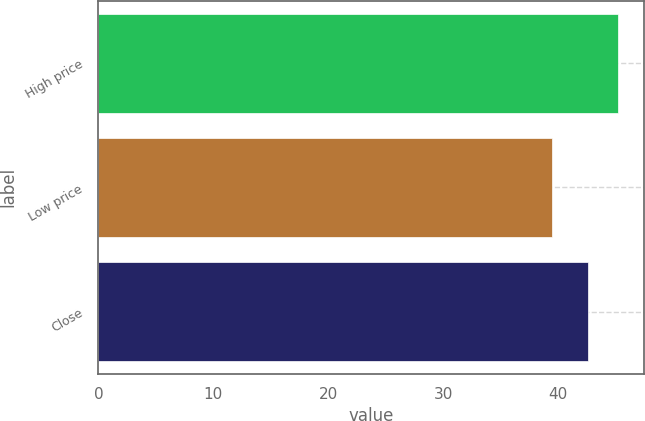Convert chart to OTSL. <chart><loc_0><loc_0><loc_500><loc_500><bar_chart><fcel>High price<fcel>Low price<fcel>Close<nl><fcel>45.27<fcel>39.51<fcel>42.61<nl></chart> 